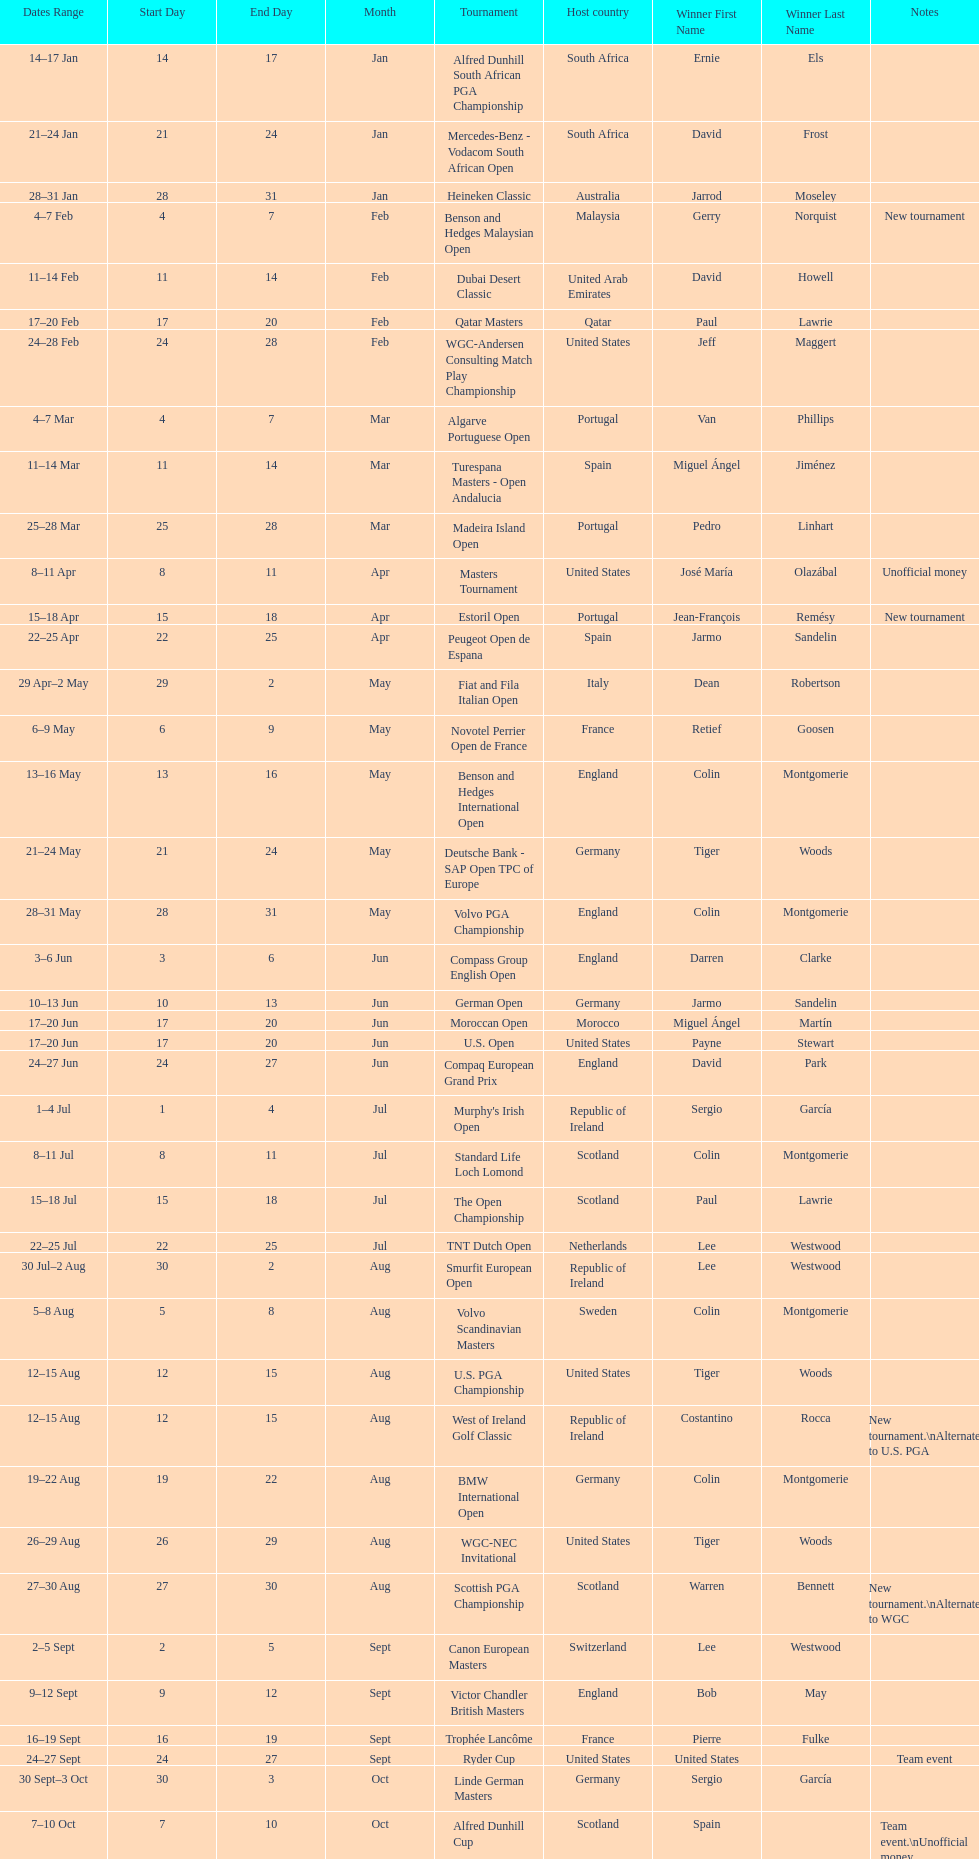How many tournaments began before aug 15th 31. 